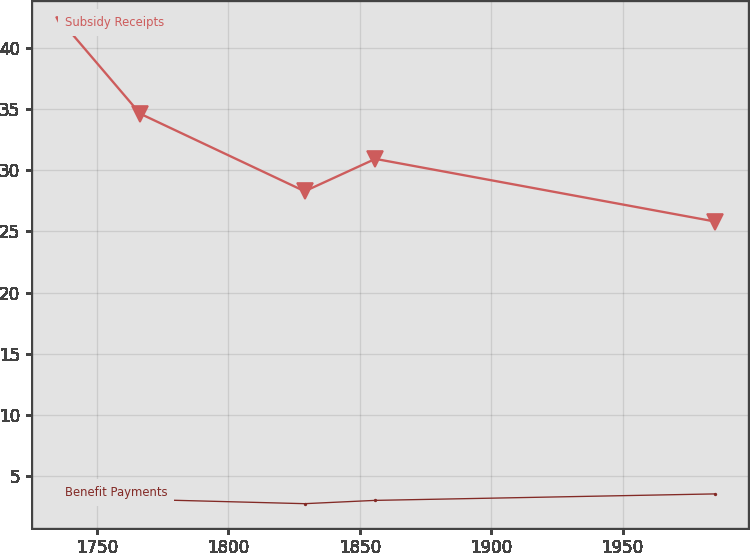Convert chart to OTSL. <chart><loc_0><loc_0><loc_500><loc_500><line_chart><ecel><fcel>Subsidy Receipts<fcel>Benefit Payments<nl><fcel>1737.57<fcel>41.9<fcel>3.45<nl><fcel>1766.37<fcel>34.64<fcel>3.08<nl><fcel>1829.02<fcel>28.29<fcel>2.73<nl><fcel>1855.89<fcel>30.94<fcel>3<nl><fcel>1985.27<fcel>25.81<fcel>3.53<nl></chart> 